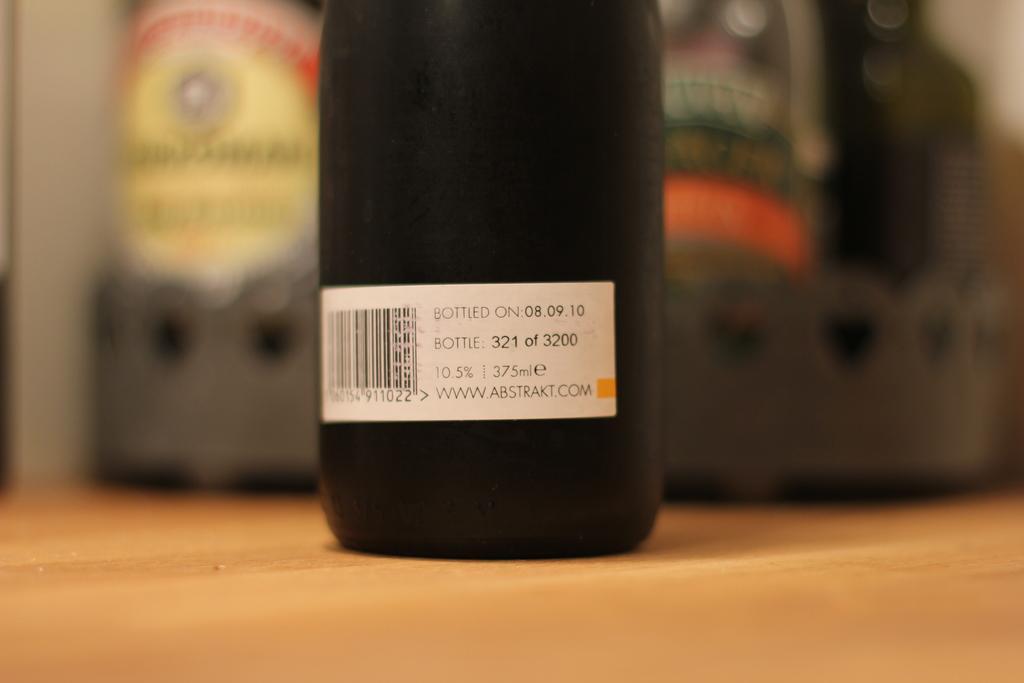How would you summarize this image in a sentence or two? In this picture we can see bottle on the wooden platform. In the background of the image it is blurry. 